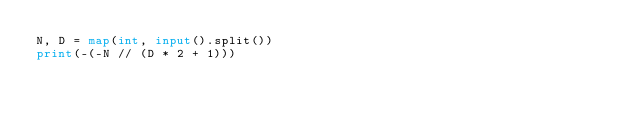Convert code to text. <code><loc_0><loc_0><loc_500><loc_500><_Python_>N, D = map(int, input().split())
print(-(-N // (D * 2 + 1)))</code> 